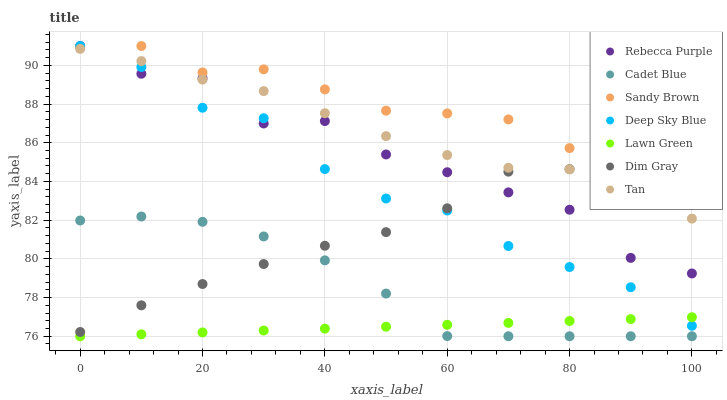Does Lawn Green have the minimum area under the curve?
Answer yes or no. Yes. Does Sandy Brown have the maximum area under the curve?
Answer yes or no. Yes. Does Dim Gray have the minimum area under the curve?
Answer yes or no. No. Does Dim Gray have the maximum area under the curve?
Answer yes or no. No. Is Lawn Green the smoothest?
Answer yes or no. Yes. Is Rebecca Purple the roughest?
Answer yes or no. Yes. Is Dim Gray the smoothest?
Answer yes or no. No. Is Dim Gray the roughest?
Answer yes or no. No. Does Lawn Green have the lowest value?
Answer yes or no. Yes. Does Dim Gray have the lowest value?
Answer yes or no. No. Does Sandy Brown have the highest value?
Answer yes or no. Yes. Does Dim Gray have the highest value?
Answer yes or no. No. Is Lawn Green less than Tan?
Answer yes or no. Yes. Is Tan greater than Lawn Green?
Answer yes or no. Yes. Does Dim Gray intersect Cadet Blue?
Answer yes or no. Yes. Is Dim Gray less than Cadet Blue?
Answer yes or no. No. Is Dim Gray greater than Cadet Blue?
Answer yes or no. No. Does Lawn Green intersect Tan?
Answer yes or no. No. 